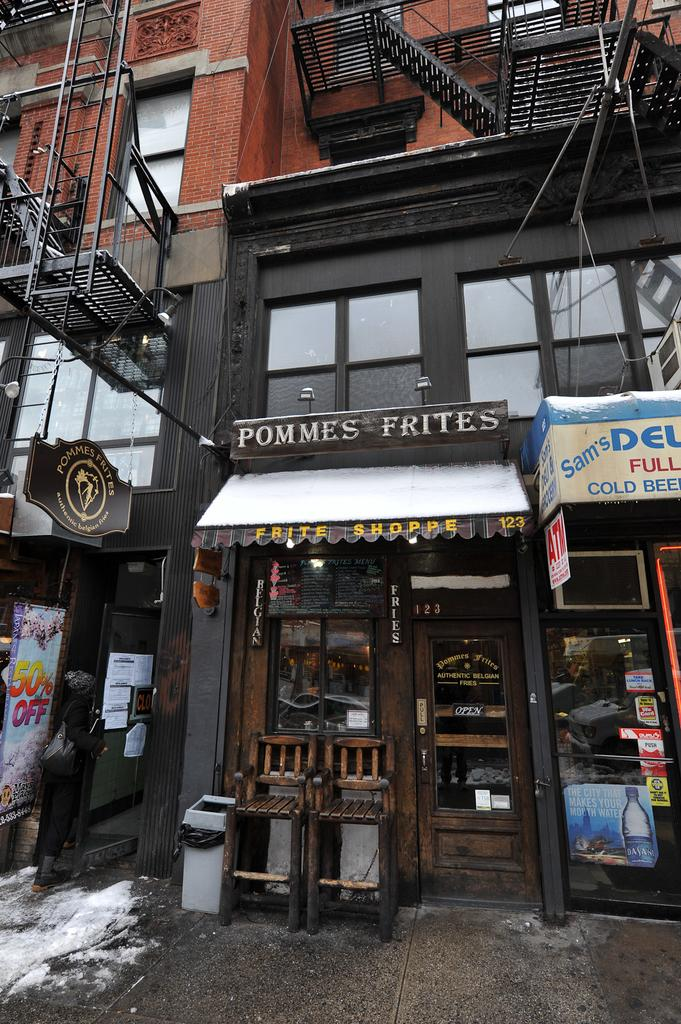What type of structure is visible in the image? There is a building in the image. What architectural feature can be seen on the building? There is a window, a door, and a staircase visible in the image. What is located on the ground in the image? There is a chair on the ground in the image. What type of surface is present in the image? There is a wall in the image. Can you describe the bushes surrounding the building in the image? There are no bushes visible in the image; only the building, window, door, chair, staircase, and wall are present. What type of haircut does the person in the image have? There is no person present in the image, so it is not possible to determine their haircut. 